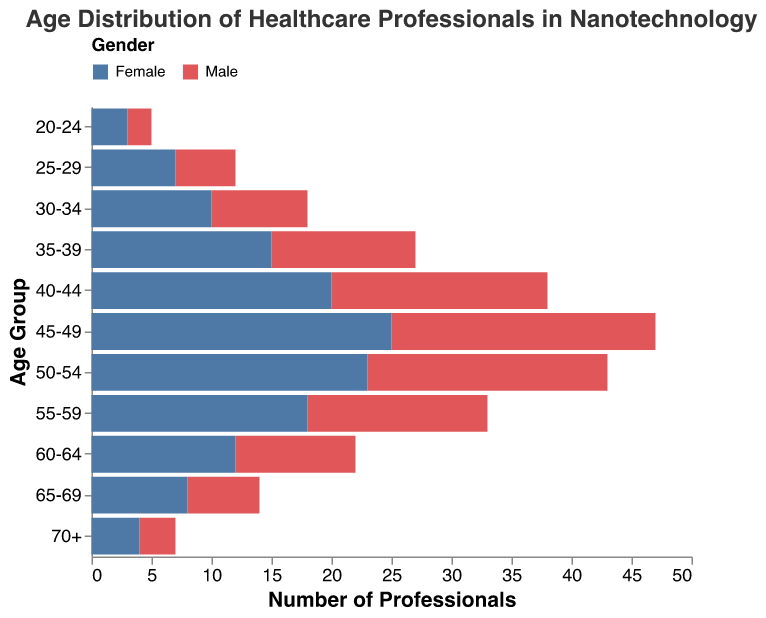What is the title of the figure? The title of the figure is located at the top and is clearly mentioned in a larger font size.
Answer: Age Distribution of Healthcare Professionals in Nanotechnology How many male professionals are in the age group 40-44? The figure shows the number of male professionals as a bar with a negative value in each age group. For the age group 40-44, the bar extends to -18.
Answer: 18 Which age group has the highest number of female healthcare professionals? To find this, look at the length of the bars representing female professionals for each age group. The age group with the longest bar is 45-49.
Answer: 45-49 How do the number of male professionals compare to female professionals in the 55-59 age group? Look at the lengths of the bars representing male and female professionals in the 55-59 age group. The male bar is at -15 and the female bar is at 18. Comparing these shows that there are more female professionals than male professionals.
Answer: More females What is the combined total number of professionals in the 30-34 age group? Add the absolute values of male and female professionals in the 30-34 age group. That is, 8 (males) + 10 (females) = 18.
Answer: 18 What is the gender ratio among professionals aged 50-54? The number of male professionals is 20 and the number of female professionals is 23. The ratio is calculated as males divided by females, 20/23.
Answer: 20:23 What is the age group with the least number of healthcare professionals? Look for the age group with the smallest total bar lengths (both male and female combined). The smallest combined number is in the 20-24 age group.
Answer: 20-24 How does the number of professionals aged 70+ compare to those aged 25-29? Sum the totals for each age group. For 70+, it’s 3 (males) + 4 (females) = 7. For 25-29, it’s 5 (males) + 7 (females) = 12. Thus, the 25-29 group has more professionals.
Answer: More in 25-29 Is there a trend in the distribution of female professionals across age groups? Observe the lengths of the female bars across age groups. They generally increase up to 45-49 and then gradually decrease.
Answer: Increases then decreases 